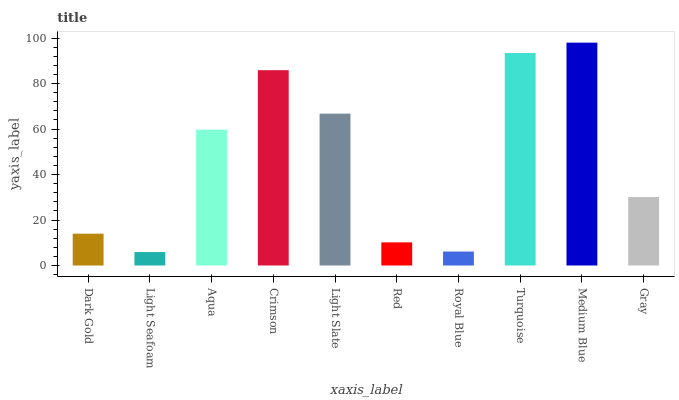Is Light Seafoam the minimum?
Answer yes or no. Yes. Is Medium Blue the maximum?
Answer yes or no. Yes. Is Aqua the minimum?
Answer yes or no. No. Is Aqua the maximum?
Answer yes or no. No. Is Aqua greater than Light Seafoam?
Answer yes or no. Yes. Is Light Seafoam less than Aqua?
Answer yes or no. Yes. Is Light Seafoam greater than Aqua?
Answer yes or no. No. Is Aqua less than Light Seafoam?
Answer yes or no. No. Is Aqua the high median?
Answer yes or no. Yes. Is Gray the low median?
Answer yes or no. Yes. Is Turquoise the high median?
Answer yes or no. No. Is Crimson the low median?
Answer yes or no. No. 